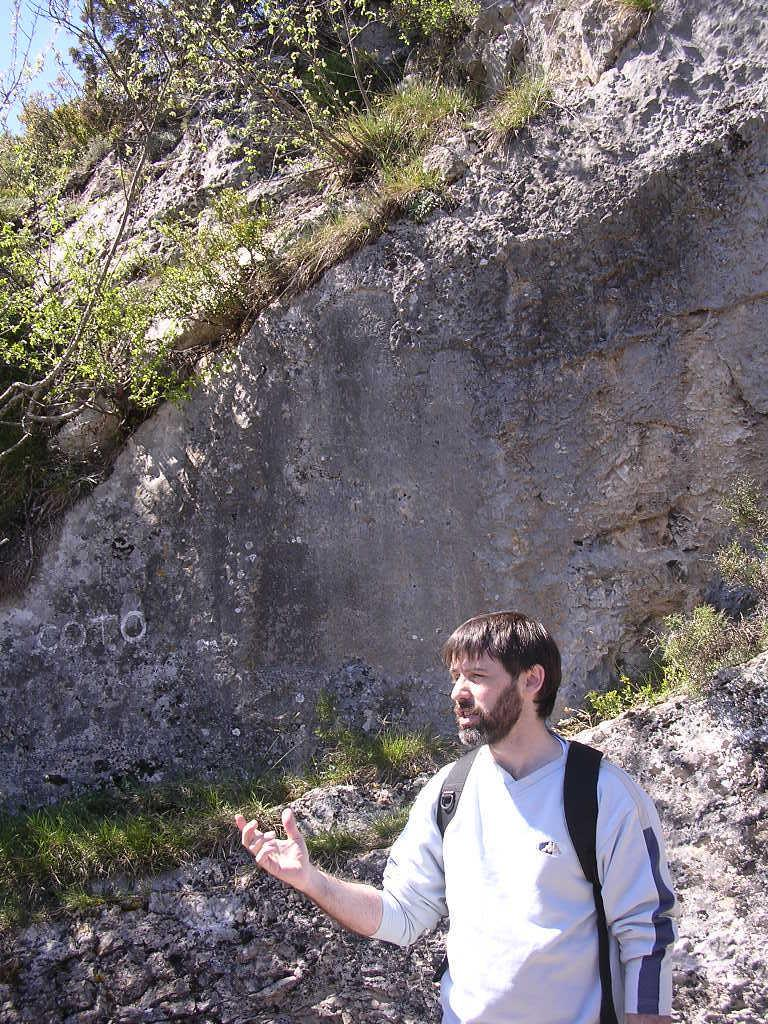What is the main subject in the foreground of the picture? There is a man in the foreground of the picture. What is the man wearing in the picture? The man is wearing a backpack. What is the man doing in the picture? The man is talking. What can be seen in the background of the picture? There is a rock, grass, plants, and the sky visible in the background of the picture. What type of friction can be observed between the man and the canvas in the image? There is no canvas present in the image, and therefore no friction can be observed between the man and a canvas. 